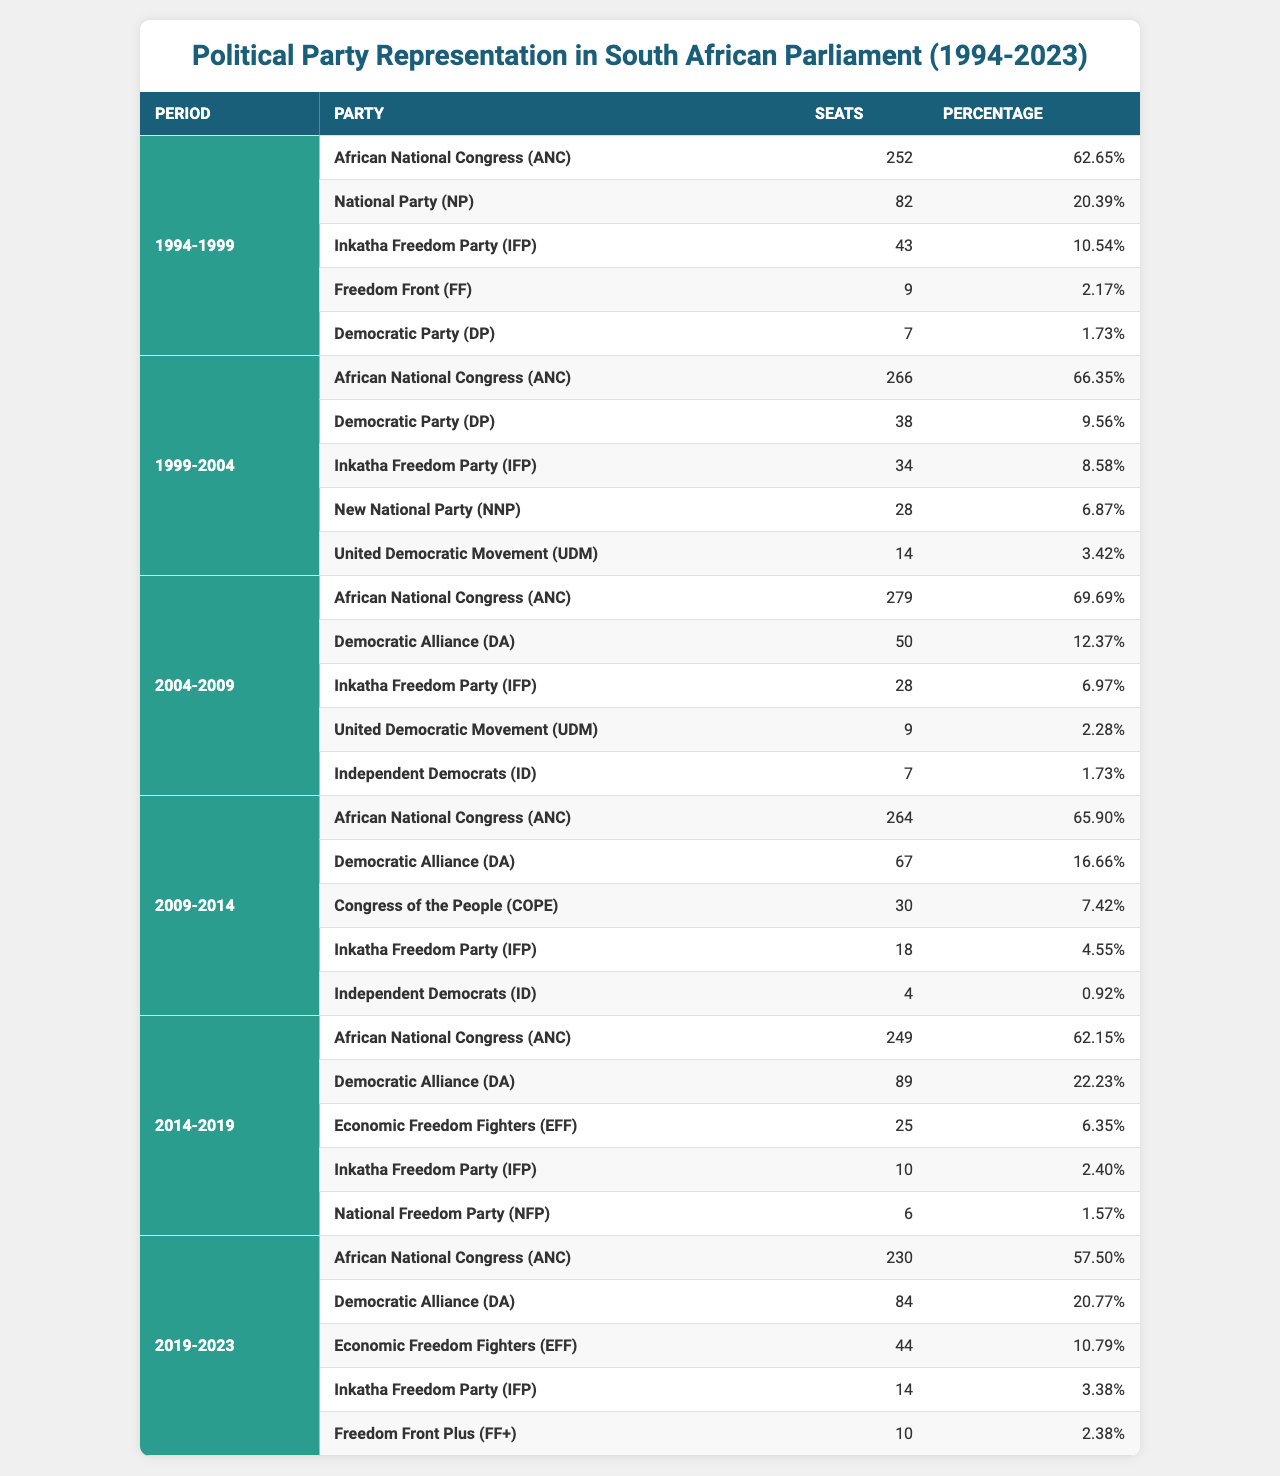What was the percentage of seats held by the African National Congress (ANC) in the 2004-2009 period? In the table, under the 2004-2009 period, the ANC is listed with a percentage of 69.69 for its seats.
Answer: 69.69 Which party had the least number of seats in the 1994-1999 period? By examining the seats listed in the 1994-1999 period, the party with the least seats is the Democratic Party (DP) with 7 seats.
Answer: Democratic Party (DP) How many seats did the Democratic Alliance (DA) have in 2009-2014 compared to 2014-2019? In the 2009-2014 period, the DA had 67 seats, while in the 2014-2019 period, it increased to 89 seats. The difference can be calculated as 89 - 67 = 22 seats more in 2014-2019.
Answer: 22 Which party consistently held more than 20% of the seats across all periods shown? The ANC consistently holds more than 20% of the seats in every period: 62.65%, 66.35%, 69.69%, 65.90%, 62.15%, and 57.50%.
Answer: African National Congress (ANC) What was the average percentage of seats held by the Inkatha Freedom Party (IFP) from 1994 to 2023? The IFP’s percentages across all periods are: 10.54 (1994-1999), 8.58 (1999-2004), 6.97 (2004-2009), 4.55 (2009-2014), 2.40 (2014-2019), and 3.38 (2019-2023). The total is 36.42, and dividing by 6 gives an average of 6.07%.
Answer: 6.07 Did the National Party (NP) increase its representation in the parliament after 1994? In the 1994-1999 period, NP had 82 seats. However, in subsequent elections, NP was replaced by the New National Party (NNP) that appeared in the 1999-2004 period with only 28 seats, indicating a decrease in representation.
Answer: No Which party saw a significant increase in seats from 2014-2019 to 2019-2023? The party that saw an increase is the Economic Freedom Fighters (EFF), with 25 seats in 2014-2019 and rising to 44 seats in 2019-2023, making a difference of 19 seats more.
Answer: Economic Freedom Fighters (EFF) 